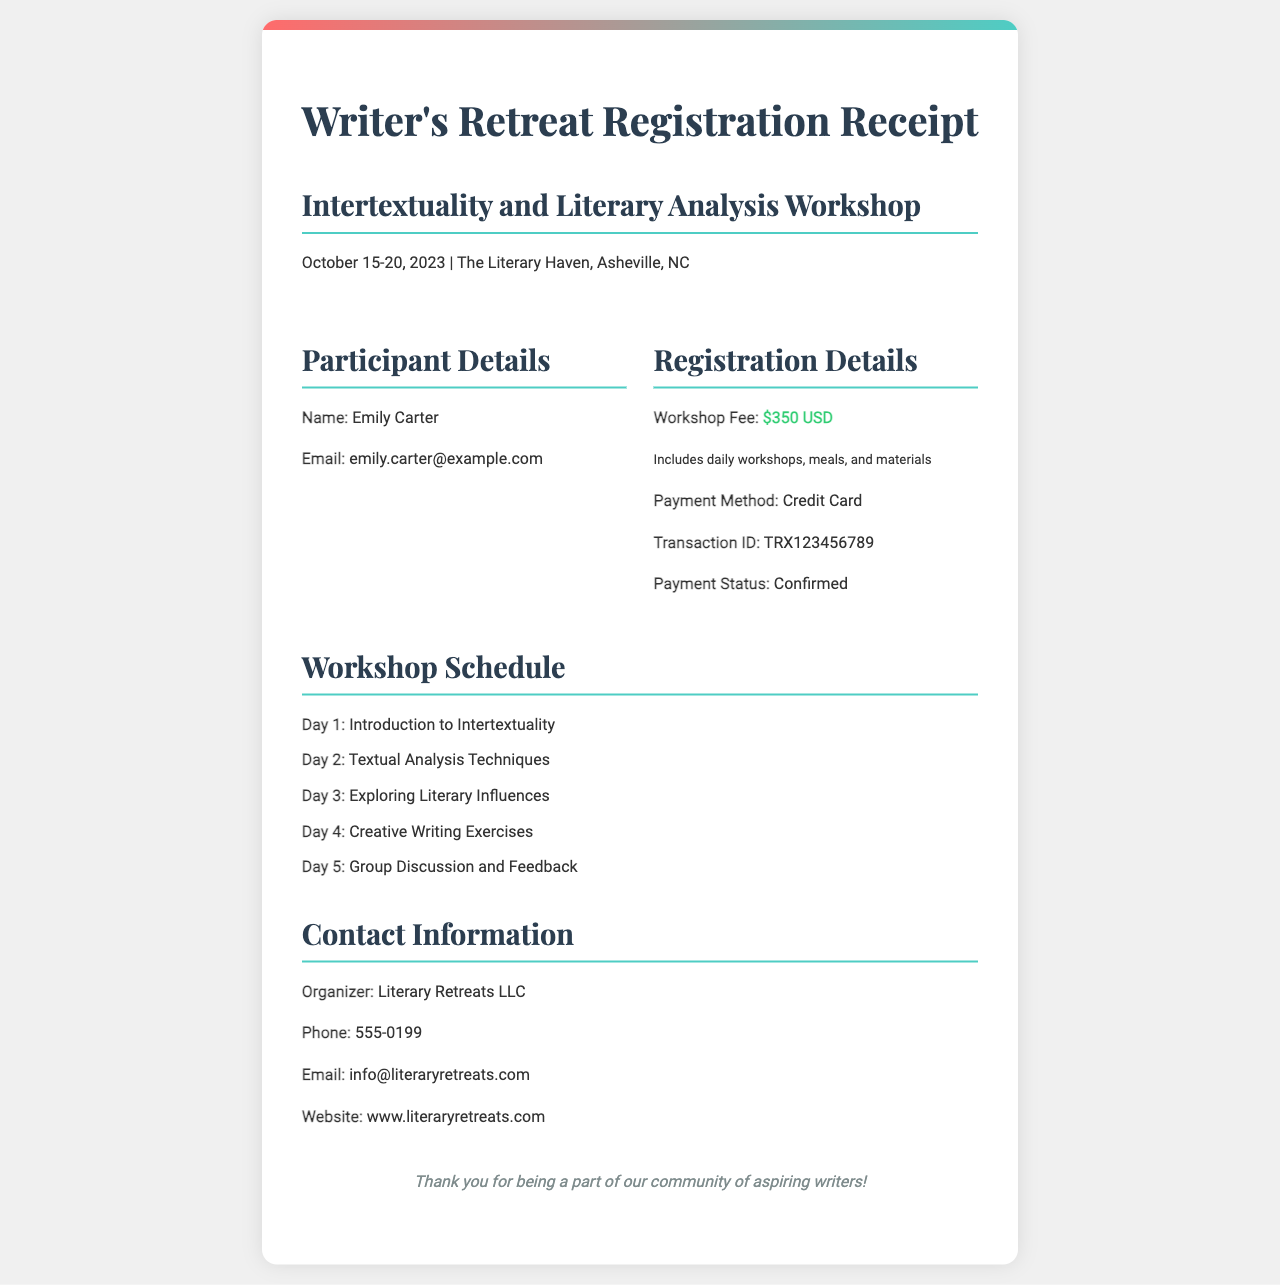What is the name of the participant? The participant's name is stated in the document under Participant Details.
Answer: Emily Carter What is the workshop fee? The workshop fee is explicitly mentioned in the Registration Details section of the document.
Answer: $350 USD What is the payment method used? The payment method is specified in the Registration Details section.
Answer: Credit Card Which days are covered in the workshop schedule? The workshop schedule lists activities for each of the five days, indicated in the schedule section of the document.
Answer: October 15-20, 2023 What is the email address of the participant? The participant's email is provided under Participant Details in the document.
Answer: emily.carter@example.com What is the transaction ID for the payment? The transaction ID is listed under Registration Details in the document.
Answer: TRX123456789 Who is the organizer of the retreat? The organizer's name is stated in the Contact Information section.
Answer: Literary Retreats LLC What is included in the workshop fee? The inclusion details are noted in the Registration Details beneath the workshop fee.
Answer: daily workshops, meals, and materials What type of document is this? The title at the top of the document indicates its purpose clearly.
Answer: Registration Receipt 